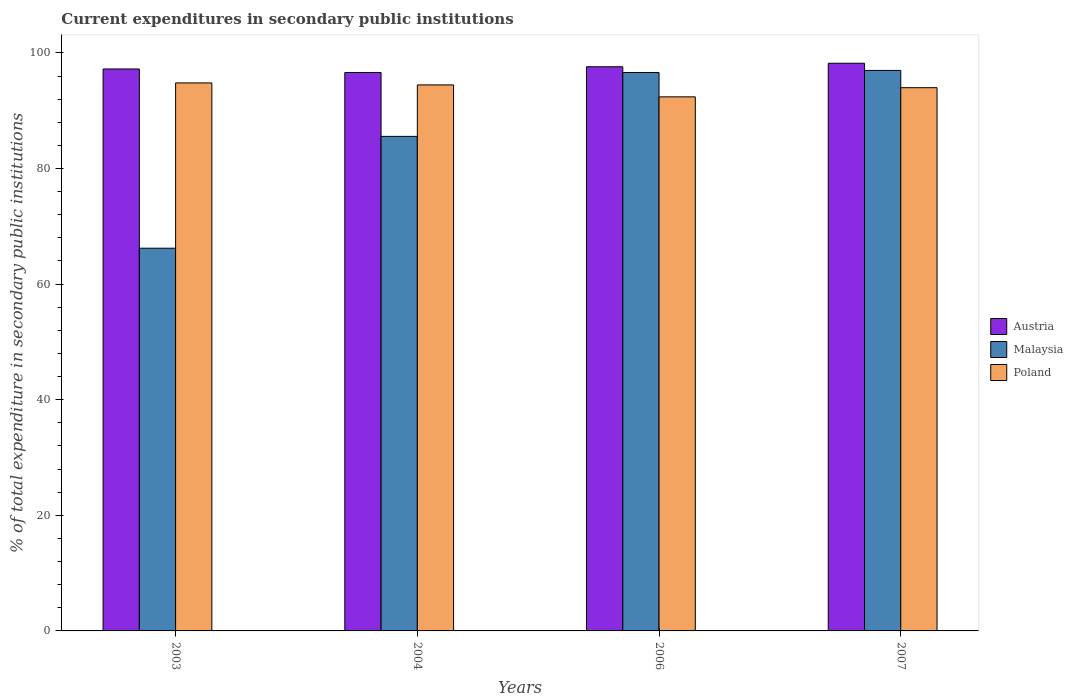How many different coloured bars are there?
Make the answer very short. 3. Are the number of bars on each tick of the X-axis equal?
Provide a succinct answer. Yes. How many bars are there on the 1st tick from the right?
Make the answer very short. 3. What is the label of the 2nd group of bars from the left?
Provide a short and direct response. 2004. In how many cases, is the number of bars for a given year not equal to the number of legend labels?
Make the answer very short. 0. What is the current expenditures in secondary public institutions in Malaysia in 2006?
Ensure brevity in your answer.  96.61. Across all years, what is the maximum current expenditures in secondary public institutions in Malaysia?
Give a very brief answer. 96.97. Across all years, what is the minimum current expenditures in secondary public institutions in Malaysia?
Provide a succinct answer. 66.21. In which year was the current expenditures in secondary public institutions in Austria maximum?
Provide a short and direct response. 2007. In which year was the current expenditures in secondary public institutions in Malaysia minimum?
Your answer should be very brief. 2003. What is the total current expenditures in secondary public institutions in Poland in the graph?
Give a very brief answer. 375.65. What is the difference between the current expenditures in secondary public institutions in Malaysia in 2003 and that in 2006?
Your answer should be very brief. -30.39. What is the difference between the current expenditures in secondary public institutions in Malaysia in 2003 and the current expenditures in secondary public institutions in Austria in 2004?
Give a very brief answer. -30.4. What is the average current expenditures in secondary public institutions in Poland per year?
Your answer should be very brief. 93.91. In the year 2004, what is the difference between the current expenditures in secondary public institutions in Malaysia and current expenditures in secondary public institutions in Poland?
Make the answer very short. -8.9. What is the ratio of the current expenditures in secondary public institutions in Poland in 2004 to that in 2006?
Offer a terse response. 1.02. Is the difference between the current expenditures in secondary public institutions in Malaysia in 2004 and 2007 greater than the difference between the current expenditures in secondary public institutions in Poland in 2004 and 2007?
Your answer should be compact. No. What is the difference between the highest and the second highest current expenditures in secondary public institutions in Malaysia?
Ensure brevity in your answer.  0.36. What is the difference between the highest and the lowest current expenditures in secondary public institutions in Austria?
Give a very brief answer. 1.6. Is the sum of the current expenditures in secondary public institutions in Austria in 2004 and 2006 greater than the maximum current expenditures in secondary public institutions in Malaysia across all years?
Your answer should be compact. Yes. What does the 1st bar from the left in 2007 represents?
Give a very brief answer. Austria. What does the 1st bar from the right in 2007 represents?
Make the answer very short. Poland. Is it the case that in every year, the sum of the current expenditures in secondary public institutions in Malaysia and current expenditures in secondary public institutions in Austria is greater than the current expenditures in secondary public institutions in Poland?
Provide a succinct answer. Yes. Does the graph contain grids?
Offer a terse response. No. Where does the legend appear in the graph?
Your answer should be very brief. Center right. How many legend labels are there?
Keep it short and to the point. 3. How are the legend labels stacked?
Make the answer very short. Vertical. What is the title of the graph?
Keep it short and to the point. Current expenditures in secondary public institutions. What is the label or title of the Y-axis?
Offer a terse response. % of total expenditure in secondary public institutions. What is the % of total expenditure in secondary public institutions of Austria in 2003?
Your answer should be very brief. 97.22. What is the % of total expenditure in secondary public institutions in Malaysia in 2003?
Your response must be concise. 66.21. What is the % of total expenditure in secondary public institutions in Poland in 2003?
Offer a terse response. 94.81. What is the % of total expenditure in secondary public institutions of Austria in 2004?
Your answer should be very brief. 96.61. What is the % of total expenditure in secondary public institutions of Malaysia in 2004?
Keep it short and to the point. 85.56. What is the % of total expenditure in secondary public institutions of Poland in 2004?
Give a very brief answer. 94.46. What is the % of total expenditure in secondary public institutions in Austria in 2006?
Provide a short and direct response. 97.6. What is the % of total expenditure in secondary public institutions in Malaysia in 2006?
Make the answer very short. 96.61. What is the % of total expenditure in secondary public institutions of Poland in 2006?
Offer a terse response. 92.4. What is the % of total expenditure in secondary public institutions in Austria in 2007?
Your response must be concise. 98.21. What is the % of total expenditure in secondary public institutions in Malaysia in 2007?
Provide a succinct answer. 96.97. What is the % of total expenditure in secondary public institutions in Poland in 2007?
Your answer should be very brief. 93.98. Across all years, what is the maximum % of total expenditure in secondary public institutions in Austria?
Ensure brevity in your answer.  98.21. Across all years, what is the maximum % of total expenditure in secondary public institutions of Malaysia?
Provide a succinct answer. 96.97. Across all years, what is the maximum % of total expenditure in secondary public institutions of Poland?
Provide a short and direct response. 94.81. Across all years, what is the minimum % of total expenditure in secondary public institutions of Austria?
Offer a very short reply. 96.61. Across all years, what is the minimum % of total expenditure in secondary public institutions of Malaysia?
Offer a very short reply. 66.21. Across all years, what is the minimum % of total expenditure in secondary public institutions of Poland?
Provide a succinct answer. 92.4. What is the total % of total expenditure in secondary public institutions in Austria in the graph?
Give a very brief answer. 389.65. What is the total % of total expenditure in secondary public institutions of Malaysia in the graph?
Your answer should be compact. 345.35. What is the total % of total expenditure in secondary public institutions in Poland in the graph?
Give a very brief answer. 375.65. What is the difference between the % of total expenditure in secondary public institutions in Austria in 2003 and that in 2004?
Your response must be concise. 0.61. What is the difference between the % of total expenditure in secondary public institutions of Malaysia in 2003 and that in 2004?
Provide a short and direct response. -19.34. What is the difference between the % of total expenditure in secondary public institutions in Poland in 2003 and that in 2004?
Make the answer very short. 0.35. What is the difference between the % of total expenditure in secondary public institutions in Austria in 2003 and that in 2006?
Give a very brief answer. -0.38. What is the difference between the % of total expenditure in secondary public institutions in Malaysia in 2003 and that in 2006?
Keep it short and to the point. -30.39. What is the difference between the % of total expenditure in secondary public institutions of Poland in 2003 and that in 2006?
Offer a very short reply. 2.41. What is the difference between the % of total expenditure in secondary public institutions of Austria in 2003 and that in 2007?
Give a very brief answer. -0.99. What is the difference between the % of total expenditure in secondary public institutions of Malaysia in 2003 and that in 2007?
Keep it short and to the point. -30.76. What is the difference between the % of total expenditure in secondary public institutions in Poland in 2003 and that in 2007?
Keep it short and to the point. 0.83. What is the difference between the % of total expenditure in secondary public institutions in Austria in 2004 and that in 2006?
Make the answer very short. -0.99. What is the difference between the % of total expenditure in secondary public institutions in Malaysia in 2004 and that in 2006?
Provide a succinct answer. -11.05. What is the difference between the % of total expenditure in secondary public institutions of Poland in 2004 and that in 2006?
Your answer should be compact. 2.07. What is the difference between the % of total expenditure in secondary public institutions of Austria in 2004 and that in 2007?
Offer a terse response. -1.6. What is the difference between the % of total expenditure in secondary public institutions of Malaysia in 2004 and that in 2007?
Make the answer very short. -11.41. What is the difference between the % of total expenditure in secondary public institutions of Poland in 2004 and that in 2007?
Your answer should be compact. 0.48. What is the difference between the % of total expenditure in secondary public institutions of Austria in 2006 and that in 2007?
Provide a succinct answer. -0.61. What is the difference between the % of total expenditure in secondary public institutions of Malaysia in 2006 and that in 2007?
Ensure brevity in your answer.  -0.36. What is the difference between the % of total expenditure in secondary public institutions in Poland in 2006 and that in 2007?
Give a very brief answer. -1.58. What is the difference between the % of total expenditure in secondary public institutions of Austria in 2003 and the % of total expenditure in secondary public institutions of Malaysia in 2004?
Your answer should be compact. 11.66. What is the difference between the % of total expenditure in secondary public institutions of Austria in 2003 and the % of total expenditure in secondary public institutions of Poland in 2004?
Your answer should be compact. 2.76. What is the difference between the % of total expenditure in secondary public institutions of Malaysia in 2003 and the % of total expenditure in secondary public institutions of Poland in 2004?
Your response must be concise. -28.25. What is the difference between the % of total expenditure in secondary public institutions of Austria in 2003 and the % of total expenditure in secondary public institutions of Malaysia in 2006?
Your answer should be compact. 0.62. What is the difference between the % of total expenditure in secondary public institutions of Austria in 2003 and the % of total expenditure in secondary public institutions of Poland in 2006?
Make the answer very short. 4.82. What is the difference between the % of total expenditure in secondary public institutions in Malaysia in 2003 and the % of total expenditure in secondary public institutions in Poland in 2006?
Provide a short and direct response. -26.18. What is the difference between the % of total expenditure in secondary public institutions of Austria in 2003 and the % of total expenditure in secondary public institutions of Malaysia in 2007?
Your answer should be compact. 0.25. What is the difference between the % of total expenditure in secondary public institutions of Austria in 2003 and the % of total expenditure in secondary public institutions of Poland in 2007?
Provide a short and direct response. 3.24. What is the difference between the % of total expenditure in secondary public institutions in Malaysia in 2003 and the % of total expenditure in secondary public institutions in Poland in 2007?
Your answer should be compact. -27.77. What is the difference between the % of total expenditure in secondary public institutions in Austria in 2004 and the % of total expenditure in secondary public institutions in Malaysia in 2006?
Provide a succinct answer. 0.01. What is the difference between the % of total expenditure in secondary public institutions of Austria in 2004 and the % of total expenditure in secondary public institutions of Poland in 2006?
Your answer should be compact. 4.21. What is the difference between the % of total expenditure in secondary public institutions in Malaysia in 2004 and the % of total expenditure in secondary public institutions in Poland in 2006?
Keep it short and to the point. -6.84. What is the difference between the % of total expenditure in secondary public institutions in Austria in 2004 and the % of total expenditure in secondary public institutions in Malaysia in 2007?
Provide a short and direct response. -0.36. What is the difference between the % of total expenditure in secondary public institutions in Austria in 2004 and the % of total expenditure in secondary public institutions in Poland in 2007?
Offer a very short reply. 2.63. What is the difference between the % of total expenditure in secondary public institutions of Malaysia in 2004 and the % of total expenditure in secondary public institutions of Poland in 2007?
Ensure brevity in your answer.  -8.42. What is the difference between the % of total expenditure in secondary public institutions of Austria in 2006 and the % of total expenditure in secondary public institutions of Malaysia in 2007?
Your response must be concise. 0.64. What is the difference between the % of total expenditure in secondary public institutions of Austria in 2006 and the % of total expenditure in secondary public institutions of Poland in 2007?
Offer a terse response. 3.62. What is the difference between the % of total expenditure in secondary public institutions in Malaysia in 2006 and the % of total expenditure in secondary public institutions in Poland in 2007?
Provide a short and direct response. 2.62. What is the average % of total expenditure in secondary public institutions of Austria per year?
Provide a short and direct response. 97.41. What is the average % of total expenditure in secondary public institutions of Malaysia per year?
Give a very brief answer. 86.34. What is the average % of total expenditure in secondary public institutions in Poland per year?
Make the answer very short. 93.91. In the year 2003, what is the difference between the % of total expenditure in secondary public institutions of Austria and % of total expenditure in secondary public institutions of Malaysia?
Your answer should be very brief. 31.01. In the year 2003, what is the difference between the % of total expenditure in secondary public institutions of Austria and % of total expenditure in secondary public institutions of Poland?
Give a very brief answer. 2.41. In the year 2003, what is the difference between the % of total expenditure in secondary public institutions of Malaysia and % of total expenditure in secondary public institutions of Poland?
Your answer should be compact. -28.6. In the year 2004, what is the difference between the % of total expenditure in secondary public institutions in Austria and % of total expenditure in secondary public institutions in Malaysia?
Your response must be concise. 11.05. In the year 2004, what is the difference between the % of total expenditure in secondary public institutions in Austria and % of total expenditure in secondary public institutions in Poland?
Your response must be concise. 2.15. In the year 2004, what is the difference between the % of total expenditure in secondary public institutions in Malaysia and % of total expenditure in secondary public institutions in Poland?
Your answer should be compact. -8.9. In the year 2006, what is the difference between the % of total expenditure in secondary public institutions of Austria and % of total expenditure in secondary public institutions of Malaysia?
Your response must be concise. 1. In the year 2006, what is the difference between the % of total expenditure in secondary public institutions in Austria and % of total expenditure in secondary public institutions in Poland?
Your answer should be very brief. 5.21. In the year 2006, what is the difference between the % of total expenditure in secondary public institutions of Malaysia and % of total expenditure in secondary public institutions of Poland?
Provide a succinct answer. 4.21. In the year 2007, what is the difference between the % of total expenditure in secondary public institutions of Austria and % of total expenditure in secondary public institutions of Malaysia?
Your answer should be very brief. 1.24. In the year 2007, what is the difference between the % of total expenditure in secondary public institutions in Austria and % of total expenditure in secondary public institutions in Poland?
Your answer should be very brief. 4.23. In the year 2007, what is the difference between the % of total expenditure in secondary public institutions in Malaysia and % of total expenditure in secondary public institutions in Poland?
Offer a very short reply. 2.99. What is the ratio of the % of total expenditure in secondary public institutions of Austria in 2003 to that in 2004?
Keep it short and to the point. 1.01. What is the ratio of the % of total expenditure in secondary public institutions of Malaysia in 2003 to that in 2004?
Keep it short and to the point. 0.77. What is the ratio of the % of total expenditure in secondary public institutions of Poland in 2003 to that in 2004?
Your response must be concise. 1. What is the ratio of the % of total expenditure in secondary public institutions in Austria in 2003 to that in 2006?
Provide a succinct answer. 1. What is the ratio of the % of total expenditure in secondary public institutions in Malaysia in 2003 to that in 2006?
Provide a succinct answer. 0.69. What is the ratio of the % of total expenditure in secondary public institutions in Poland in 2003 to that in 2006?
Offer a terse response. 1.03. What is the ratio of the % of total expenditure in secondary public institutions in Austria in 2003 to that in 2007?
Provide a short and direct response. 0.99. What is the ratio of the % of total expenditure in secondary public institutions of Malaysia in 2003 to that in 2007?
Provide a succinct answer. 0.68. What is the ratio of the % of total expenditure in secondary public institutions in Poland in 2003 to that in 2007?
Provide a succinct answer. 1.01. What is the ratio of the % of total expenditure in secondary public institutions of Malaysia in 2004 to that in 2006?
Offer a terse response. 0.89. What is the ratio of the % of total expenditure in secondary public institutions of Poland in 2004 to that in 2006?
Offer a very short reply. 1.02. What is the ratio of the % of total expenditure in secondary public institutions of Austria in 2004 to that in 2007?
Your answer should be compact. 0.98. What is the ratio of the % of total expenditure in secondary public institutions of Malaysia in 2004 to that in 2007?
Keep it short and to the point. 0.88. What is the ratio of the % of total expenditure in secondary public institutions in Poland in 2004 to that in 2007?
Offer a terse response. 1.01. What is the ratio of the % of total expenditure in secondary public institutions of Austria in 2006 to that in 2007?
Your response must be concise. 0.99. What is the ratio of the % of total expenditure in secondary public institutions in Poland in 2006 to that in 2007?
Your answer should be very brief. 0.98. What is the difference between the highest and the second highest % of total expenditure in secondary public institutions of Austria?
Provide a succinct answer. 0.61. What is the difference between the highest and the second highest % of total expenditure in secondary public institutions in Malaysia?
Offer a very short reply. 0.36. What is the difference between the highest and the second highest % of total expenditure in secondary public institutions in Poland?
Offer a very short reply. 0.35. What is the difference between the highest and the lowest % of total expenditure in secondary public institutions of Austria?
Ensure brevity in your answer.  1.6. What is the difference between the highest and the lowest % of total expenditure in secondary public institutions of Malaysia?
Your answer should be very brief. 30.76. What is the difference between the highest and the lowest % of total expenditure in secondary public institutions in Poland?
Provide a short and direct response. 2.41. 